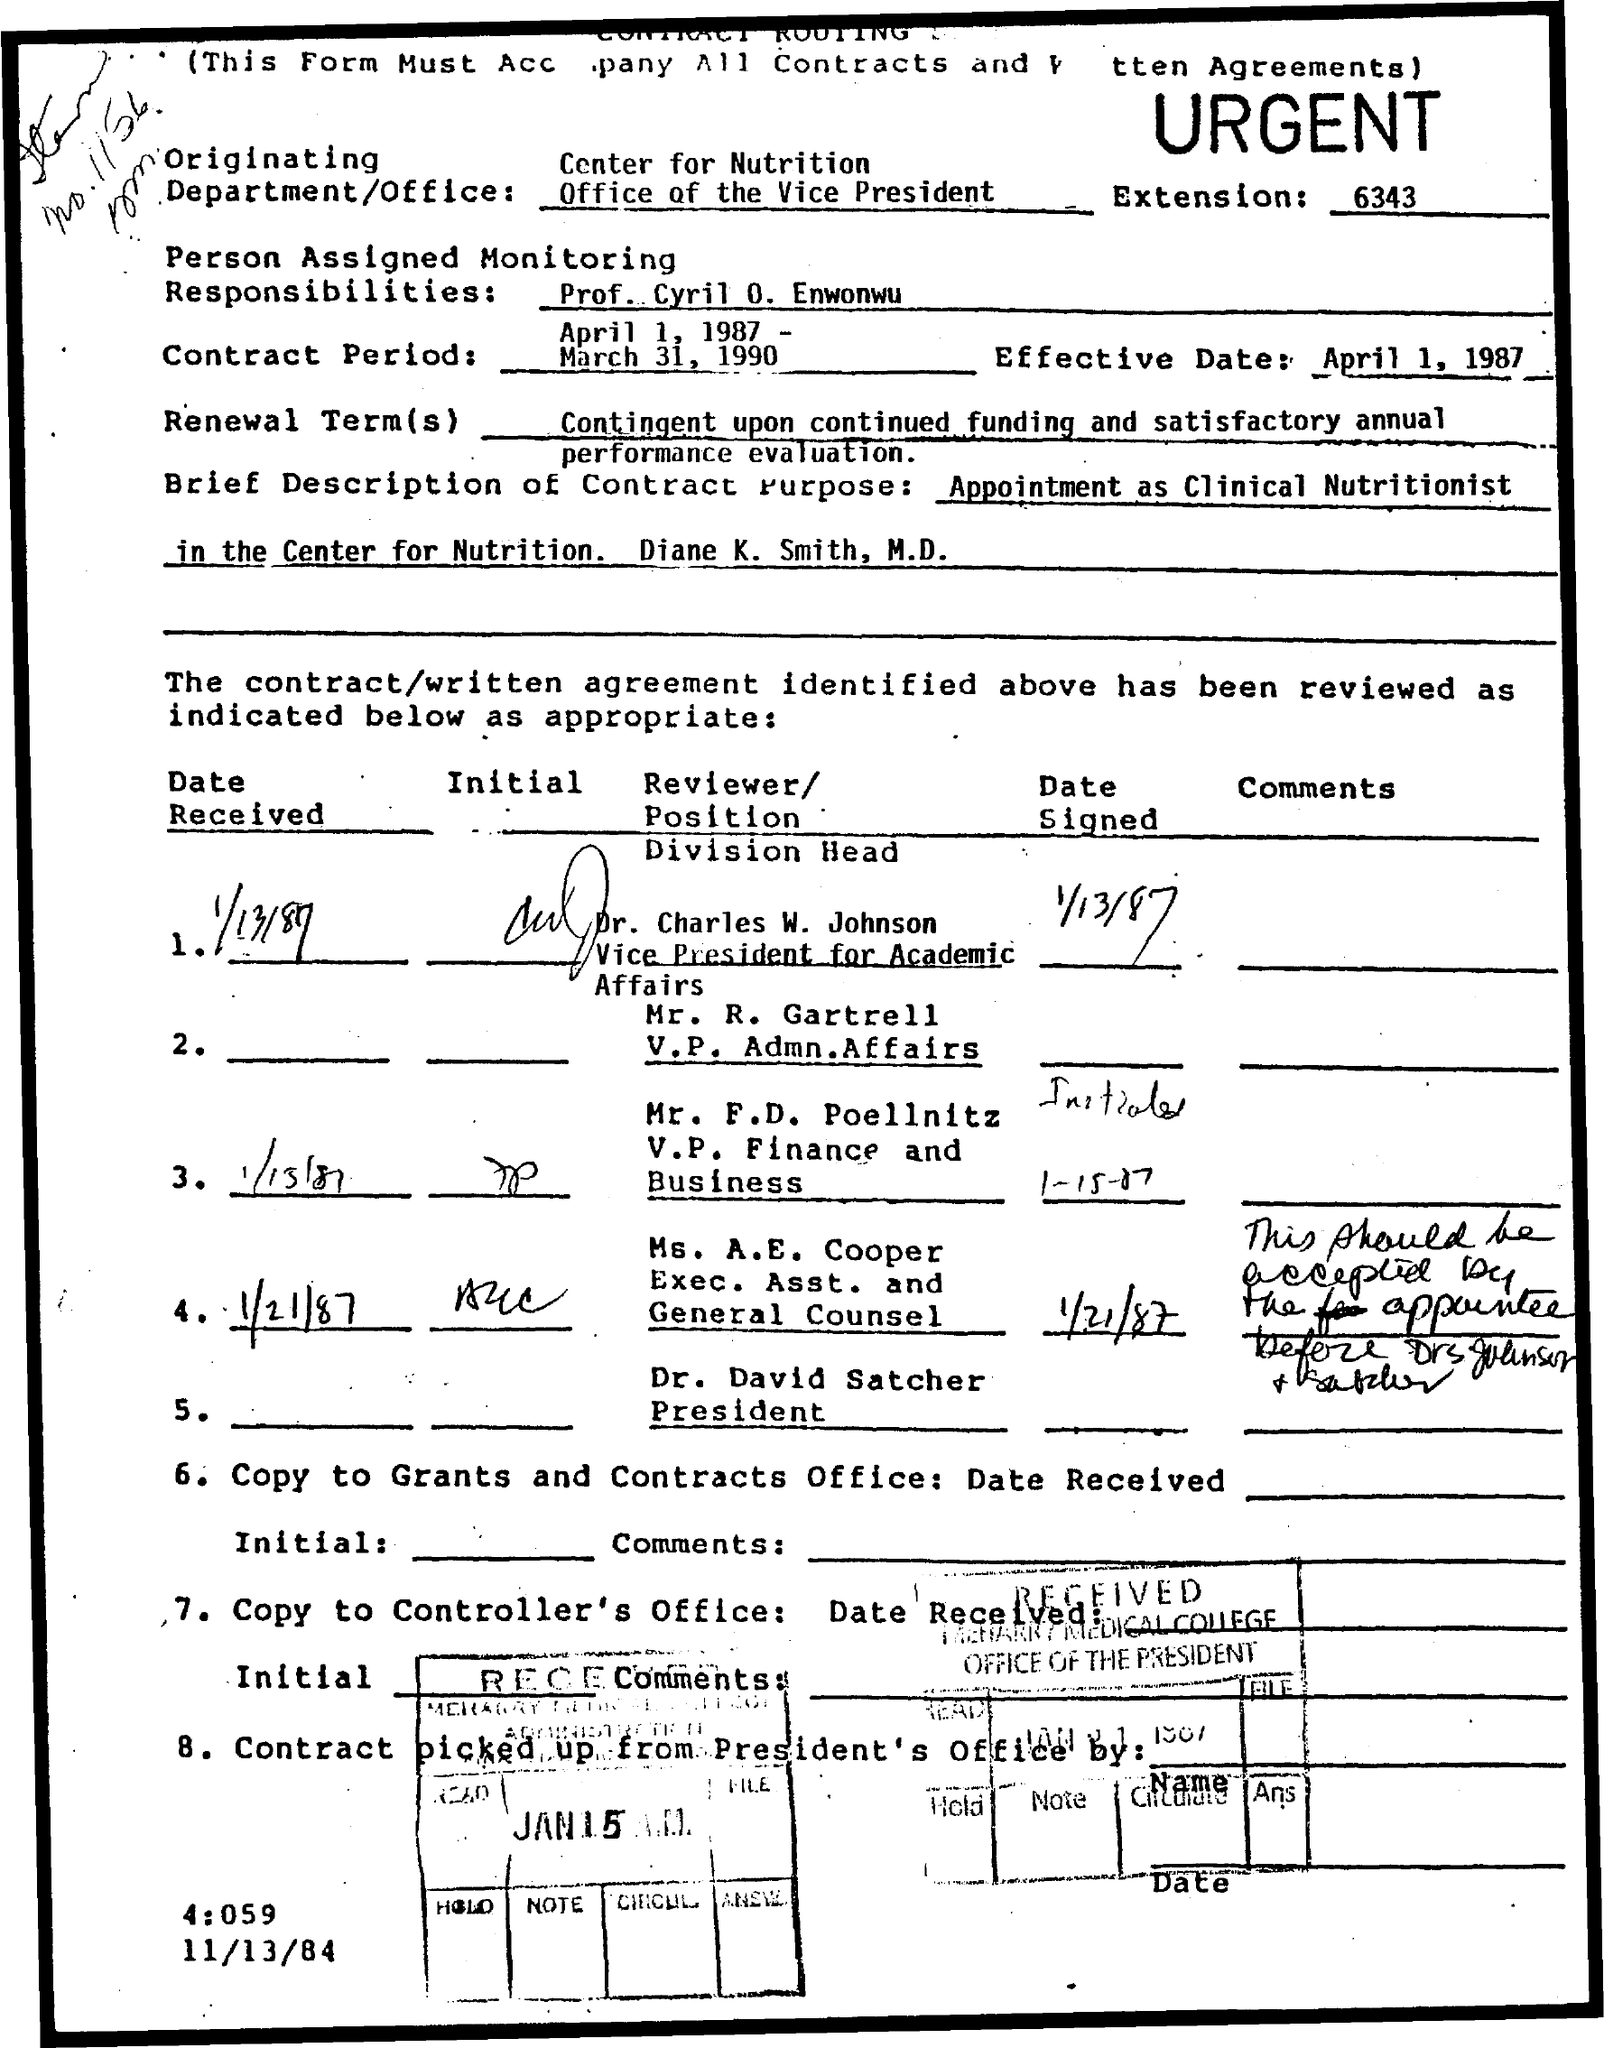Mention a couple of crucial points in this snapshot. What is the extension?" is a question that is being asked. The number after the question mark is 6343. The effective date of April 1, 1987, has been noted. The person assigned monitoring responsibilities is Prof. Cyril O. Enwonwu. The Contract period is from April 1, 1987, to March 31, 1990. 